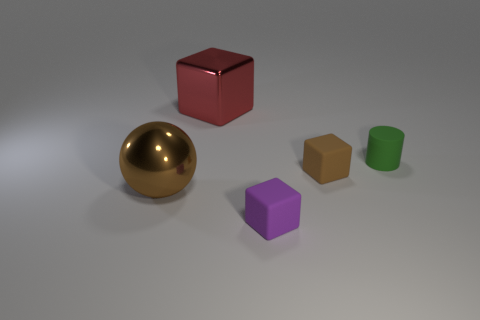Is the shape of the small green matte thing the same as the tiny purple thing?
Offer a terse response. No. What number of things are cylinders right of the brown rubber object or things that are behind the small purple object?
Offer a terse response. 4. How many things are either red metallic objects or small cubes?
Make the answer very short. 3. There is a big metallic object that is right of the large sphere; what number of small cubes are behind it?
Your response must be concise. 0. What number of other objects are the same size as the brown cube?
Your answer should be compact. 2. There is a matte thing that is the same color as the big shiny sphere; what is its size?
Your response must be concise. Small. There is a brown thing on the left side of the small purple block; is it the same shape as the small green thing?
Your answer should be very brief. No. What material is the tiny block that is behind the sphere?
Your response must be concise. Rubber. Is there a tiny blue cylinder made of the same material as the red cube?
Ensure brevity in your answer.  No. The red thing has what size?
Give a very brief answer. Large. 